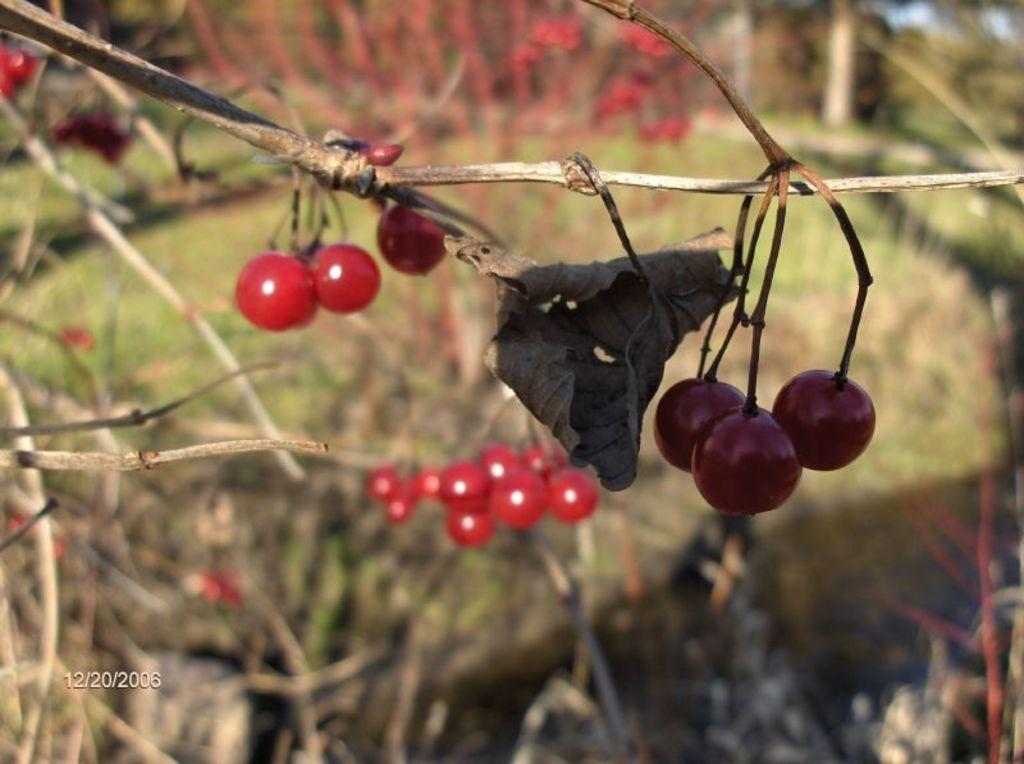What type of fruit can be seen on the plants in the image? There are berries on plants in the image. What can be observed about the background of the image? The background of the image is blurred. Is there any additional information or branding present in the image? Yes, there is a watermark in the image. Can you see any deer interacting with the berries in the image? There are no deer present in the image; it only features berries on plants. What type of apparatus is being used to harvest the berries in the image? There is no apparatus visible in the image; it only shows berries on plants. 